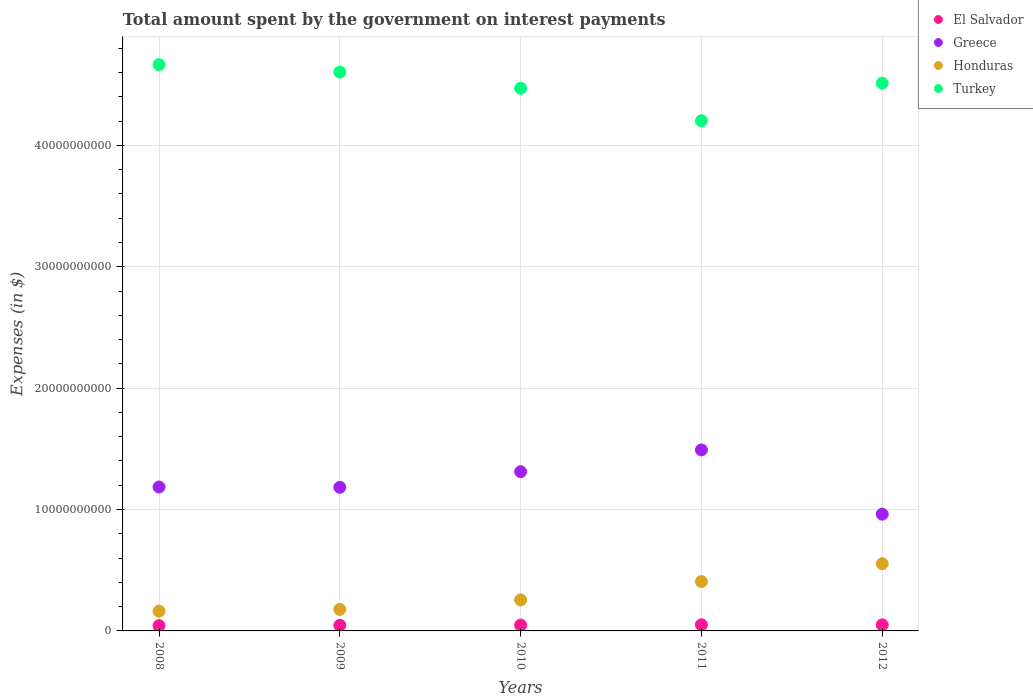How many different coloured dotlines are there?
Provide a succinct answer. 4. Is the number of dotlines equal to the number of legend labels?
Give a very brief answer. Yes. What is the amount spent on interest payments by the government in El Salvador in 2010?
Keep it short and to the point. 4.79e+08. Across all years, what is the maximum amount spent on interest payments by the government in El Salvador?
Give a very brief answer. 5.07e+08. Across all years, what is the minimum amount spent on interest payments by the government in Honduras?
Offer a terse response. 1.63e+09. In which year was the amount spent on interest payments by the government in El Salvador maximum?
Provide a succinct answer. 2011. In which year was the amount spent on interest payments by the government in Turkey minimum?
Offer a terse response. 2011. What is the total amount spent on interest payments by the government in Turkey in the graph?
Keep it short and to the point. 2.25e+11. What is the difference between the amount spent on interest payments by the government in Greece in 2008 and that in 2011?
Give a very brief answer. -3.06e+09. What is the difference between the amount spent on interest payments by the government in Honduras in 2011 and the amount spent on interest payments by the government in El Salvador in 2012?
Your answer should be compact. 3.57e+09. What is the average amount spent on interest payments by the government in Turkey per year?
Provide a succinct answer. 4.49e+1. In the year 2012, what is the difference between the amount spent on interest payments by the government in El Salvador and amount spent on interest payments by the government in Honduras?
Make the answer very short. -5.04e+09. What is the ratio of the amount spent on interest payments by the government in Honduras in 2009 to that in 2012?
Offer a terse response. 0.32. Is the difference between the amount spent on interest payments by the government in El Salvador in 2010 and 2012 greater than the difference between the amount spent on interest payments by the government in Honduras in 2010 and 2012?
Give a very brief answer. Yes. What is the difference between the highest and the second highest amount spent on interest payments by the government in Greece?
Provide a short and direct response. 1.79e+09. What is the difference between the highest and the lowest amount spent on interest payments by the government in Honduras?
Ensure brevity in your answer.  3.91e+09. Is the sum of the amount spent on interest payments by the government in Honduras in 2011 and 2012 greater than the maximum amount spent on interest payments by the government in El Salvador across all years?
Make the answer very short. Yes. Is the amount spent on interest payments by the government in Turkey strictly less than the amount spent on interest payments by the government in El Salvador over the years?
Your answer should be very brief. No. How many years are there in the graph?
Ensure brevity in your answer.  5. What is the difference between two consecutive major ticks on the Y-axis?
Your response must be concise. 1.00e+1. Does the graph contain any zero values?
Offer a terse response. No. Where does the legend appear in the graph?
Ensure brevity in your answer.  Top right. How many legend labels are there?
Provide a succinct answer. 4. What is the title of the graph?
Ensure brevity in your answer.  Total amount spent by the government on interest payments. What is the label or title of the Y-axis?
Your answer should be compact. Expenses (in $). What is the Expenses (in $) in El Salvador in 2008?
Your answer should be compact. 4.32e+08. What is the Expenses (in $) of Greece in 2008?
Ensure brevity in your answer.  1.19e+1. What is the Expenses (in $) of Honduras in 2008?
Offer a terse response. 1.63e+09. What is the Expenses (in $) in Turkey in 2008?
Ensure brevity in your answer.  4.67e+1. What is the Expenses (in $) of El Salvador in 2009?
Provide a succinct answer. 4.59e+08. What is the Expenses (in $) of Greece in 2009?
Give a very brief answer. 1.18e+1. What is the Expenses (in $) of Honduras in 2009?
Keep it short and to the point. 1.77e+09. What is the Expenses (in $) in Turkey in 2009?
Offer a very short reply. 4.60e+1. What is the Expenses (in $) in El Salvador in 2010?
Provide a short and direct response. 4.79e+08. What is the Expenses (in $) in Greece in 2010?
Offer a terse response. 1.31e+1. What is the Expenses (in $) of Honduras in 2010?
Offer a very short reply. 2.55e+09. What is the Expenses (in $) of Turkey in 2010?
Your response must be concise. 4.47e+1. What is the Expenses (in $) of El Salvador in 2011?
Keep it short and to the point. 5.07e+08. What is the Expenses (in $) in Greece in 2011?
Offer a terse response. 1.49e+1. What is the Expenses (in $) of Honduras in 2011?
Give a very brief answer. 4.07e+09. What is the Expenses (in $) of Turkey in 2011?
Provide a short and direct response. 4.20e+1. What is the Expenses (in $) of El Salvador in 2012?
Ensure brevity in your answer.  4.97e+08. What is the Expenses (in $) of Greece in 2012?
Offer a very short reply. 9.62e+09. What is the Expenses (in $) of Honduras in 2012?
Keep it short and to the point. 5.54e+09. What is the Expenses (in $) in Turkey in 2012?
Your answer should be compact. 4.51e+1. Across all years, what is the maximum Expenses (in $) in El Salvador?
Your answer should be very brief. 5.07e+08. Across all years, what is the maximum Expenses (in $) in Greece?
Offer a terse response. 1.49e+1. Across all years, what is the maximum Expenses (in $) in Honduras?
Your answer should be very brief. 5.54e+09. Across all years, what is the maximum Expenses (in $) in Turkey?
Provide a short and direct response. 4.67e+1. Across all years, what is the minimum Expenses (in $) of El Salvador?
Make the answer very short. 4.32e+08. Across all years, what is the minimum Expenses (in $) of Greece?
Offer a terse response. 9.62e+09. Across all years, what is the minimum Expenses (in $) in Honduras?
Offer a terse response. 1.63e+09. Across all years, what is the minimum Expenses (in $) of Turkey?
Your answer should be very brief. 4.20e+1. What is the total Expenses (in $) of El Salvador in the graph?
Provide a succinct answer. 2.37e+09. What is the total Expenses (in $) in Greece in the graph?
Offer a very short reply. 6.13e+1. What is the total Expenses (in $) of Honduras in the graph?
Provide a succinct answer. 1.56e+1. What is the total Expenses (in $) in Turkey in the graph?
Offer a terse response. 2.25e+11. What is the difference between the Expenses (in $) in El Salvador in 2008 and that in 2009?
Your response must be concise. -2.70e+07. What is the difference between the Expenses (in $) of Greece in 2008 and that in 2009?
Your answer should be compact. 2.30e+07. What is the difference between the Expenses (in $) in Honduras in 2008 and that in 2009?
Offer a very short reply. -1.49e+08. What is the difference between the Expenses (in $) of Turkey in 2008 and that in 2009?
Provide a short and direct response. 6.15e+08. What is the difference between the Expenses (in $) of El Salvador in 2008 and that in 2010?
Ensure brevity in your answer.  -4.65e+07. What is the difference between the Expenses (in $) in Greece in 2008 and that in 2010?
Provide a short and direct response. -1.26e+09. What is the difference between the Expenses (in $) of Honduras in 2008 and that in 2010?
Ensure brevity in your answer.  -9.29e+08. What is the difference between the Expenses (in $) in Turkey in 2008 and that in 2010?
Your response must be concise. 1.95e+09. What is the difference between the Expenses (in $) in El Salvador in 2008 and that in 2011?
Provide a succinct answer. -7.42e+07. What is the difference between the Expenses (in $) in Greece in 2008 and that in 2011?
Make the answer very short. -3.06e+09. What is the difference between the Expenses (in $) of Honduras in 2008 and that in 2011?
Your answer should be very brief. -2.44e+09. What is the difference between the Expenses (in $) in Turkey in 2008 and that in 2011?
Your answer should be very brief. 4.62e+09. What is the difference between the Expenses (in $) in El Salvador in 2008 and that in 2012?
Give a very brief answer. -6.51e+07. What is the difference between the Expenses (in $) of Greece in 2008 and that in 2012?
Make the answer very short. 2.24e+09. What is the difference between the Expenses (in $) of Honduras in 2008 and that in 2012?
Your response must be concise. -3.91e+09. What is the difference between the Expenses (in $) of Turkey in 2008 and that in 2012?
Provide a succinct answer. 1.53e+09. What is the difference between the Expenses (in $) in El Salvador in 2009 and that in 2010?
Offer a very short reply. -1.95e+07. What is the difference between the Expenses (in $) of Greece in 2009 and that in 2010?
Keep it short and to the point. -1.29e+09. What is the difference between the Expenses (in $) of Honduras in 2009 and that in 2010?
Ensure brevity in your answer.  -7.80e+08. What is the difference between the Expenses (in $) of Turkey in 2009 and that in 2010?
Give a very brief answer. 1.33e+09. What is the difference between the Expenses (in $) of El Salvador in 2009 and that in 2011?
Provide a succinct answer. -4.72e+07. What is the difference between the Expenses (in $) of Greece in 2009 and that in 2011?
Offer a terse response. -3.08e+09. What is the difference between the Expenses (in $) in Honduras in 2009 and that in 2011?
Offer a terse response. -2.29e+09. What is the difference between the Expenses (in $) of Turkey in 2009 and that in 2011?
Offer a very short reply. 4.01e+09. What is the difference between the Expenses (in $) in El Salvador in 2009 and that in 2012?
Provide a succinct answer. -3.81e+07. What is the difference between the Expenses (in $) of Greece in 2009 and that in 2012?
Your response must be concise. 2.21e+09. What is the difference between the Expenses (in $) of Honduras in 2009 and that in 2012?
Keep it short and to the point. -3.76e+09. What is the difference between the Expenses (in $) of Turkey in 2009 and that in 2012?
Make the answer very short. 9.15e+08. What is the difference between the Expenses (in $) of El Salvador in 2010 and that in 2011?
Keep it short and to the point. -2.77e+07. What is the difference between the Expenses (in $) of Greece in 2010 and that in 2011?
Your answer should be very brief. -1.79e+09. What is the difference between the Expenses (in $) of Honduras in 2010 and that in 2011?
Give a very brief answer. -1.51e+09. What is the difference between the Expenses (in $) of Turkey in 2010 and that in 2011?
Give a very brief answer. 2.68e+09. What is the difference between the Expenses (in $) in El Salvador in 2010 and that in 2012?
Keep it short and to the point. -1.86e+07. What is the difference between the Expenses (in $) of Greece in 2010 and that in 2012?
Give a very brief answer. 3.50e+09. What is the difference between the Expenses (in $) of Honduras in 2010 and that in 2012?
Offer a terse response. -2.98e+09. What is the difference between the Expenses (in $) in Turkey in 2010 and that in 2012?
Your response must be concise. -4.16e+08. What is the difference between the Expenses (in $) in El Salvador in 2011 and that in 2012?
Provide a succinct answer. 9.12e+06. What is the difference between the Expenses (in $) in Greece in 2011 and that in 2012?
Provide a succinct answer. 5.29e+09. What is the difference between the Expenses (in $) of Honduras in 2011 and that in 2012?
Give a very brief answer. -1.47e+09. What is the difference between the Expenses (in $) in Turkey in 2011 and that in 2012?
Give a very brief answer. -3.09e+09. What is the difference between the Expenses (in $) of El Salvador in 2008 and the Expenses (in $) of Greece in 2009?
Keep it short and to the point. -1.14e+1. What is the difference between the Expenses (in $) in El Salvador in 2008 and the Expenses (in $) in Honduras in 2009?
Offer a terse response. -1.34e+09. What is the difference between the Expenses (in $) of El Salvador in 2008 and the Expenses (in $) of Turkey in 2009?
Your response must be concise. -4.56e+1. What is the difference between the Expenses (in $) of Greece in 2008 and the Expenses (in $) of Honduras in 2009?
Offer a terse response. 1.01e+1. What is the difference between the Expenses (in $) of Greece in 2008 and the Expenses (in $) of Turkey in 2009?
Provide a succinct answer. -3.42e+1. What is the difference between the Expenses (in $) in Honduras in 2008 and the Expenses (in $) in Turkey in 2009?
Ensure brevity in your answer.  -4.44e+1. What is the difference between the Expenses (in $) in El Salvador in 2008 and the Expenses (in $) in Greece in 2010?
Keep it short and to the point. -1.27e+1. What is the difference between the Expenses (in $) of El Salvador in 2008 and the Expenses (in $) of Honduras in 2010?
Your response must be concise. -2.12e+09. What is the difference between the Expenses (in $) of El Salvador in 2008 and the Expenses (in $) of Turkey in 2010?
Your answer should be compact. -4.43e+1. What is the difference between the Expenses (in $) of Greece in 2008 and the Expenses (in $) of Honduras in 2010?
Offer a very short reply. 9.30e+09. What is the difference between the Expenses (in $) in Greece in 2008 and the Expenses (in $) in Turkey in 2010?
Ensure brevity in your answer.  -3.29e+1. What is the difference between the Expenses (in $) of Honduras in 2008 and the Expenses (in $) of Turkey in 2010?
Give a very brief answer. -4.31e+1. What is the difference between the Expenses (in $) of El Salvador in 2008 and the Expenses (in $) of Greece in 2011?
Your answer should be compact. -1.45e+1. What is the difference between the Expenses (in $) of El Salvador in 2008 and the Expenses (in $) of Honduras in 2011?
Offer a terse response. -3.63e+09. What is the difference between the Expenses (in $) of El Salvador in 2008 and the Expenses (in $) of Turkey in 2011?
Offer a very short reply. -4.16e+1. What is the difference between the Expenses (in $) of Greece in 2008 and the Expenses (in $) of Honduras in 2011?
Your answer should be very brief. 7.79e+09. What is the difference between the Expenses (in $) in Greece in 2008 and the Expenses (in $) in Turkey in 2011?
Your response must be concise. -3.02e+1. What is the difference between the Expenses (in $) in Honduras in 2008 and the Expenses (in $) in Turkey in 2011?
Offer a very short reply. -4.04e+1. What is the difference between the Expenses (in $) in El Salvador in 2008 and the Expenses (in $) in Greece in 2012?
Your answer should be very brief. -9.18e+09. What is the difference between the Expenses (in $) of El Salvador in 2008 and the Expenses (in $) of Honduras in 2012?
Provide a succinct answer. -5.11e+09. What is the difference between the Expenses (in $) in El Salvador in 2008 and the Expenses (in $) in Turkey in 2012?
Keep it short and to the point. -4.47e+1. What is the difference between the Expenses (in $) in Greece in 2008 and the Expenses (in $) in Honduras in 2012?
Your response must be concise. 6.32e+09. What is the difference between the Expenses (in $) of Greece in 2008 and the Expenses (in $) of Turkey in 2012?
Keep it short and to the point. -3.33e+1. What is the difference between the Expenses (in $) in Honduras in 2008 and the Expenses (in $) in Turkey in 2012?
Make the answer very short. -4.35e+1. What is the difference between the Expenses (in $) in El Salvador in 2009 and the Expenses (in $) in Greece in 2010?
Ensure brevity in your answer.  -1.27e+1. What is the difference between the Expenses (in $) of El Salvador in 2009 and the Expenses (in $) of Honduras in 2010?
Your response must be concise. -2.10e+09. What is the difference between the Expenses (in $) in El Salvador in 2009 and the Expenses (in $) in Turkey in 2010?
Make the answer very short. -4.42e+1. What is the difference between the Expenses (in $) in Greece in 2009 and the Expenses (in $) in Honduras in 2010?
Your answer should be very brief. 9.28e+09. What is the difference between the Expenses (in $) of Greece in 2009 and the Expenses (in $) of Turkey in 2010?
Your answer should be very brief. -3.29e+1. What is the difference between the Expenses (in $) in Honduras in 2009 and the Expenses (in $) in Turkey in 2010?
Offer a terse response. -4.29e+1. What is the difference between the Expenses (in $) of El Salvador in 2009 and the Expenses (in $) of Greece in 2011?
Keep it short and to the point. -1.45e+1. What is the difference between the Expenses (in $) of El Salvador in 2009 and the Expenses (in $) of Honduras in 2011?
Give a very brief answer. -3.61e+09. What is the difference between the Expenses (in $) in El Salvador in 2009 and the Expenses (in $) in Turkey in 2011?
Your answer should be compact. -4.16e+1. What is the difference between the Expenses (in $) of Greece in 2009 and the Expenses (in $) of Honduras in 2011?
Give a very brief answer. 7.76e+09. What is the difference between the Expenses (in $) in Greece in 2009 and the Expenses (in $) in Turkey in 2011?
Ensure brevity in your answer.  -3.02e+1. What is the difference between the Expenses (in $) in Honduras in 2009 and the Expenses (in $) in Turkey in 2011?
Your answer should be compact. -4.03e+1. What is the difference between the Expenses (in $) of El Salvador in 2009 and the Expenses (in $) of Greece in 2012?
Give a very brief answer. -9.16e+09. What is the difference between the Expenses (in $) in El Salvador in 2009 and the Expenses (in $) in Honduras in 2012?
Give a very brief answer. -5.08e+09. What is the difference between the Expenses (in $) of El Salvador in 2009 and the Expenses (in $) of Turkey in 2012?
Keep it short and to the point. -4.47e+1. What is the difference between the Expenses (in $) in Greece in 2009 and the Expenses (in $) in Honduras in 2012?
Give a very brief answer. 6.29e+09. What is the difference between the Expenses (in $) in Greece in 2009 and the Expenses (in $) in Turkey in 2012?
Your answer should be compact. -3.33e+1. What is the difference between the Expenses (in $) in Honduras in 2009 and the Expenses (in $) in Turkey in 2012?
Ensure brevity in your answer.  -4.33e+1. What is the difference between the Expenses (in $) of El Salvador in 2010 and the Expenses (in $) of Greece in 2011?
Your answer should be very brief. -1.44e+1. What is the difference between the Expenses (in $) in El Salvador in 2010 and the Expenses (in $) in Honduras in 2011?
Your response must be concise. -3.59e+09. What is the difference between the Expenses (in $) in El Salvador in 2010 and the Expenses (in $) in Turkey in 2011?
Provide a short and direct response. -4.15e+1. What is the difference between the Expenses (in $) of Greece in 2010 and the Expenses (in $) of Honduras in 2011?
Provide a short and direct response. 9.05e+09. What is the difference between the Expenses (in $) in Greece in 2010 and the Expenses (in $) in Turkey in 2011?
Offer a very short reply. -2.89e+1. What is the difference between the Expenses (in $) of Honduras in 2010 and the Expenses (in $) of Turkey in 2011?
Ensure brevity in your answer.  -3.95e+1. What is the difference between the Expenses (in $) in El Salvador in 2010 and the Expenses (in $) in Greece in 2012?
Your answer should be compact. -9.14e+09. What is the difference between the Expenses (in $) of El Salvador in 2010 and the Expenses (in $) of Honduras in 2012?
Keep it short and to the point. -5.06e+09. What is the difference between the Expenses (in $) in El Salvador in 2010 and the Expenses (in $) in Turkey in 2012?
Your answer should be very brief. -4.46e+1. What is the difference between the Expenses (in $) in Greece in 2010 and the Expenses (in $) in Honduras in 2012?
Offer a very short reply. 7.58e+09. What is the difference between the Expenses (in $) in Greece in 2010 and the Expenses (in $) in Turkey in 2012?
Provide a succinct answer. -3.20e+1. What is the difference between the Expenses (in $) in Honduras in 2010 and the Expenses (in $) in Turkey in 2012?
Ensure brevity in your answer.  -4.26e+1. What is the difference between the Expenses (in $) in El Salvador in 2011 and the Expenses (in $) in Greece in 2012?
Make the answer very short. -9.11e+09. What is the difference between the Expenses (in $) of El Salvador in 2011 and the Expenses (in $) of Honduras in 2012?
Offer a very short reply. -5.03e+09. What is the difference between the Expenses (in $) of El Salvador in 2011 and the Expenses (in $) of Turkey in 2012?
Keep it short and to the point. -4.46e+1. What is the difference between the Expenses (in $) in Greece in 2011 and the Expenses (in $) in Honduras in 2012?
Your response must be concise. 9.37e+09. What is the difference between the Expenses (in $) of Greece in 2011 and the Expenses (in $) of Turkey in 2012?
Keep it short and to the point. -3.02e+1. What is the difference between the Expenses (in $) of Honduras in 2011 and the Expenses (in $) of Turkey in 2012?
Provide a succinct answer. -4.11e+1. What is the average Expenses (in $) of El Salvador per year?
Your answer should be very brief. 4.75e+08. What is the average Expenses (in $) in Greece per year?
Ensure brevity in your answer.  1.23e+1. What is the average Expenses (in $) in Honduras per year?
Keep it short and to the point. 3.11e+09. What is the average Expenses (in $) in Turkey per year?
Give a very brief answer. 4.49e+1. In the year 2008, what is the difference between the Expenses (in $) in El Salvador and Expenses (in $) in Greece?
Give a very brief answer. -1.14e+1. In the year 2008, what is the difference between the Expenses (in $) in El Salvador and Expenses (in $) in Honduras?
Give a very brief answer. -1.19e+09. In the year 2008, what is the difference between the Expenses (in $) of El Salvador and Expenses (in $) of Turkey?
Provide a succinct answer. -4.62e+1. In the year 2008, what is the difference between the Expenses (in $) of Greece and Expenses (in $) of Honduras?
Ensure brevity in your answer.  1.02e+1. In the year 2008, what is the difference between the Expenses (in $) of Greece and Expenses (in $) of Turkey?
Offer a very short reply. -3.48e+1. In the year 2008, what is the difference between the Expenses (in $) of Honduras and Expenses (in $) of Turkey?
Make the answer very short. -4.50e+1. In the year 2009, what is the difference between the Expenses (in $) of El Salvador and Expenses (in $) of Greece?
Give a very brief answer. -1.14e+1. In the year 2009, what is the difference between the Expenses (in $) of El Salvador and Expenses (in $) of Honduras?
Offer a terse response. -1.32e+09. In the year 2009, what is the difference between the Expenses (in $) of El Salvador and Expenses (in $) of Turkey?
Offer a very short reply. -4.56e+1. In the year 2009, what is the difference between the Expenses (in $) of Greece and Expenses (in $) of Honduras?
Provide a short and direct response. 1.01e+1. In the year 2009, what is the difference between the Expenses (in $) of Greece and Expenses (in $) of Turkey?
Offer a terse response. -3.42e+1. In the year 2009, what is the difference between the Expenses (in $) of Honduras and Expenses (in $) of Turkey?
Give a very brief answer. -4.43e+1. In the year 2010, what is the difference between the Expenses (in $) of El Salvador and Expenses (in $) of Greece?
Offer a very short reply. -1.26e+1. In the year 2010, what is the difference between the Expenses (in $) of El Salvador and Expenses (in $) of Honduras?
Your answer should be compact. -2.08e+09. In the year 2010, what is the difference between the Expenses (in $) of El Salvador and Expenses (in $) of Turkey?
Offer a very short reply. -4.42e+1. In the year 2010, what is the difference between the Expenses (in $) in Greece and Expenses (in $) in Honduras?
Your answer should be very brief. 1.06e+1. In the year 2010, what is the difference between the Expenses (in $) of Greece and Expenses (in $) of Turkey?
Give a very brief answer. -3.16e+1. In the year 2010, what is the difference between the Expenses (in $) of Honduras and Expenses (in $) of Turkey?
Give a very brief answer. -4.21e+1. In the year 2011, what is the difference between the Expenses (in $) of El Salvador and Expenses (in $) of Greece?
Give a very brief answer. -1.44e+1. In the year 2011, what is the difference between the Expenses (in $) of El Salvador and Expenses (in $) of Honduras?
Make the answer very short. -3.56e+09. In the year 2011, what is the difference between the Expenses (in $) in El Salvador and Expenses (in $) in Turkey?
Keep it short and to the point. -4.15e+1. In the year 2011, what is the difference between the Expenses (in $) of Greece and Expenses (in $) of Honduras?
Keep it short and to the point. 1.08e+1. In the year 2011, what is the difference between the Expenses (in $) in Greece and Expenses (in $) in Turkey?
Provide a short and direct response. -2.71e+1. In the year 2011, what is the difference between the Expenses (in $) in Honduras and Expenses (in $) in Turkey?
Keep it short and to the point. -3.80e+1. In the year 2012, what is the difference between the Expenses (in $) in El Salvador and Expenses (in $) in Greece?
Make the answer very short. -9.12e+09. In the year 2012, what is the difference between the Expenses (in $) in El Salvador and Expenses (in $) in Honduras?
Your response must be concise. -5.04e+09. In the year 2012, what is the difference between the Expenses (in $) in El Salvador and Expenses (in $) in Turkey?
Provide a short and direct response. -4.46e+1. In the year 2012, what is the difference between the Expenses (in $) of Greece and Expenses (in $) of Honduras?
Offer a terse response. 4.08e+09. In the year 2012, what is the difference between the Expenses (in $) of Greece and Expenses (in $) of Turkey?
Provide a short and direct response. -3.55e+1. In the year 2012, what is the difference between the Expenses (in $) of Honduras and Expenses (in $) of Turkey?
Your answer should be very brief. -3.96e+1. What is the ratio of the Expenses (in $) of El Salvador in 2008 to that in 2009?
Your response must be concise. 0.94. What is the ratio of the Expenses (in $) in Greece in 2008 to that in 2009?
Ensure brevity in your answer.  1. What is the ratio of the Expenses (in $) of Honduras in 2008 to that in 2009?
Ensure brevity in your answer.  0.92. What is the ratio of the Expenses (in $) in Turkey in 2008 to that in 2009?
Give a very brief answer. 1.01. What is the ratio of the Expenses (in $) in El Salvador in 2008 to that in 2010?
Your answer should be compact. 0.9. What is the ratio of the Expenses (in $) in Greece in 2008 to that in 2010?
Ensure brevity in your answer.  0.9. What is the ratio of the Expenses (in $) of Honduras in 2008 to that in 2010?
Make the answer very short. 0.64. What is the ratio of the Expenses (in $) in Turkey in 2008 to that in 2010?
Provide a short and direct response. 1.04. What is the ratio of the Expenses (in $) in El Salvador in 2008 to that in 2011?
Offer a terse response. 0.85. What is the ratio of the Expenses (in $) in Greece in 2008 to that in 2011?
Your answer should be compact. 0.8. What is the ratio of the Expenses (in $) of Honduras in 2008 to that in 2011?
Your response must be concise. 0.4. What is the ratio of the Expenses (in $) of Turkey in 2008 to that in 2011?
Your response must be concise. 1.11. What is the ratio of the Expenses (in $) of El Salvador in 2008 to that in 2012?
Make the answer very short. 0.87. What is the ratio of the Expenses (in $) of Greece in 2008 to that in 2012?
Give a very brief answer. 1.23. What is the ratio of the Expenses (in $) in Honduras in 2008 to that in 2012?
Provide a short and direct response. 0.29. What is the ratio of the Expenses (in $) in Turkey in 2008 to that in 2012?
Ensure brevity in your answer.  1.03. What is the ratio of the Expenses (in $) of El Salvador in 2009 to that in 2010?
Offer a terse response. 0.96. What is the ratio of the Expenses (in $) of Greece in 2009 to that in 2010?
Offer a terse response. 0.9. What is the ratio of the Expenses (in $) of Honduras in 2009 to that in 2010?
Provide a succinct answer. 0.69. What is the ratio of the Expenses (in $) in Turkey in 2009 to that in 2010?
Your answer should be compact. 1.03. What is the ratio of the Expenses (in $) of El Salvador in 2009 to that in 2011?
Keep it short and to the point. 0.91. What is the ratio of the Expenses (in $) in Greece in 2009 to that in 2011?
Your response must be concise. 0.79. What is the ratio of the Expenses (in $) in Honduras in 2009 to that in 2011?
Your answer should be compact. 0.44. What is the ratio of the Expenses (in $) in Turkey in 2009 to that in 2011?
Provide a succinct answer. 1.1. What is the ratio of the Expenses (in $) in El Salvador in 2009 to that in 2012?
Your response must be concise. 0.92. What is the ratio of the Expenses (in $) of Greece in 2009 to that in 2012?
Make the answer very short. 1.23. What is the ratio of the Expenses (in $) of Honduras in 2009 to that in 2012?
Provide a short and direct response. 0.32. What is the ratio of the Expenses (in $) in Turkey in 2009 to that in 2012?
Offer a very short reply. 1.02. What is the ratio of the Expenses (in $) in El Salvador in 2010 to that in 2011?
Keep it short and to the point. 0.95. What is the ratio of the Expenses (in $) in Greece in 2010 to that in 2011?
Give a very brief answer. 0.88. What is the ratio of the Expenses (in $) of Honduras in 2010 to that in 2011?
Give a very brief answer. 0.63. What is the ratio of the Expenses (in $) of Turkey in 2010 to that in 2011?
Make the answer very short. 1.06. What is the ratio of the Expenses (in $) in El Salvador in 2010 to that in 2012?
Keep it short and to the point. 0.96. What is the ratio of the Expenses (in $) of Greece in 2010 to that in 2012?
Your response must be concise. 1.36. What is the ratio of the Expenses (in $) of Honduras in 2010 to that in 2012?
Offer a terse response. 0.46. What is the ratio of the Expenses (in $) of El Salvador in 2011 to that in 2012?
Make the answer very short. 1.02. What is the ratio of the Expenses (in $) of Greece in 2011 to that in 2012?
Ensure brevity in your answer.  1.55. What is the ratio of the Expenses (in $) of Honduras in 2011 to that in 2012?
Offer a terse response. 0.73. What is the ratio of the Expenses (in $) in Turkey in 2011 to that in 2012?
Keep it short and to the point. 0.93. What is the difference between the highest and the second highest Expenses (in $) of El Salvador?
Provide a short and direct response. 9.12e+06. What is the difference between the highest and the second highest Expenses (in $) of Greece?
Offer a terse response. 1.79e+09. What is the difference between the highest and the second highest Expenses (in $) of Honduras?
Provide a short and direct response. 1.47e+09. What is the difference between the highest and the second highest Expenses (in $) of Turkey?
Offer a very short reply. 6.15e+08. What is the difference between the highest and the lowest Expenses (in $) of El Salvador?
Provide a succinct answer. 7.42e+07. What is the difference between the highest and the lowest Expenses (in $) in Greece?
Make the answer very short. 5.29e+09. What is the difference between the highest and the lowest Expenses (in $) of Honduras?
Provide a succinct answer. 3.91e+09. What is the difference between the highest and the lowest Expenses (in $) in Turkey?
Give a very brief answer. 4.62e+09. 